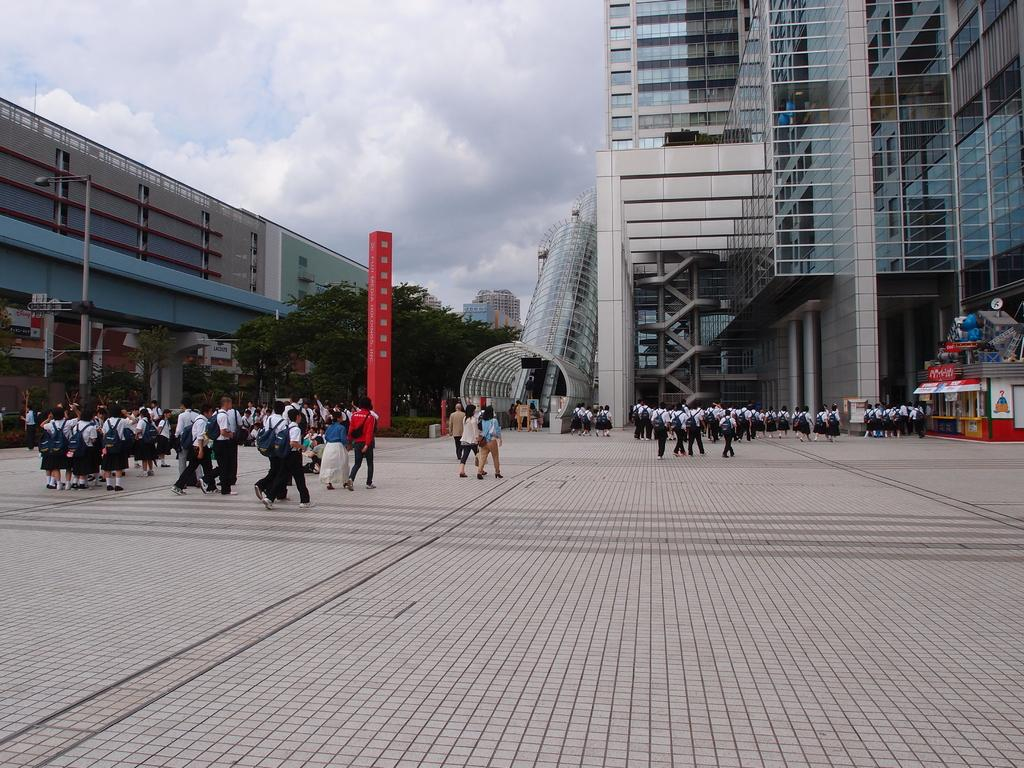Who or what can be seen in the image? There are people in the image. What type of natural elements are present in the image? There are trees and plants in the image. What man-made structures can be seen in the image? There are buildings and a pole in the image. What is visible in the background of the image? The sky is visible in the background of the image, and there are clouds in the sky. What channel is the boy watching on the pole in the image? There is no boy or television channel mentioned in the image; it only features people, trees, plants, buildings, a pole, and the sky with clouds. 